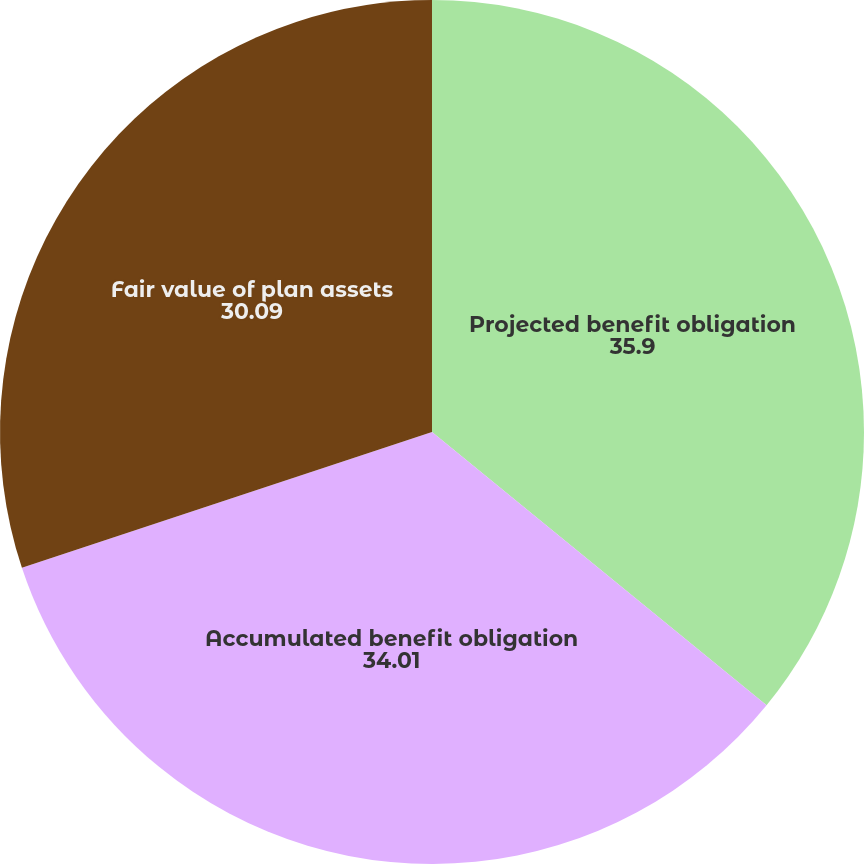Convert chart. <chart><loc_0><loc_0><loc_500><loc_500><pie_chart><fcel>Projected benefit obligation<fcel>Accumulated benefit obligation<fcel>Fair value of plan assets<nl><fcel>35.9%<fcel>34.01%<fcel>30.09%<nl></chart> 